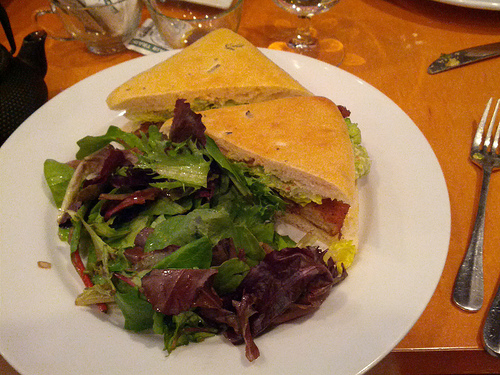On which side of the photo is the knife? The knife is on the right side of the image, next to the fork and partly under the sandwich. 